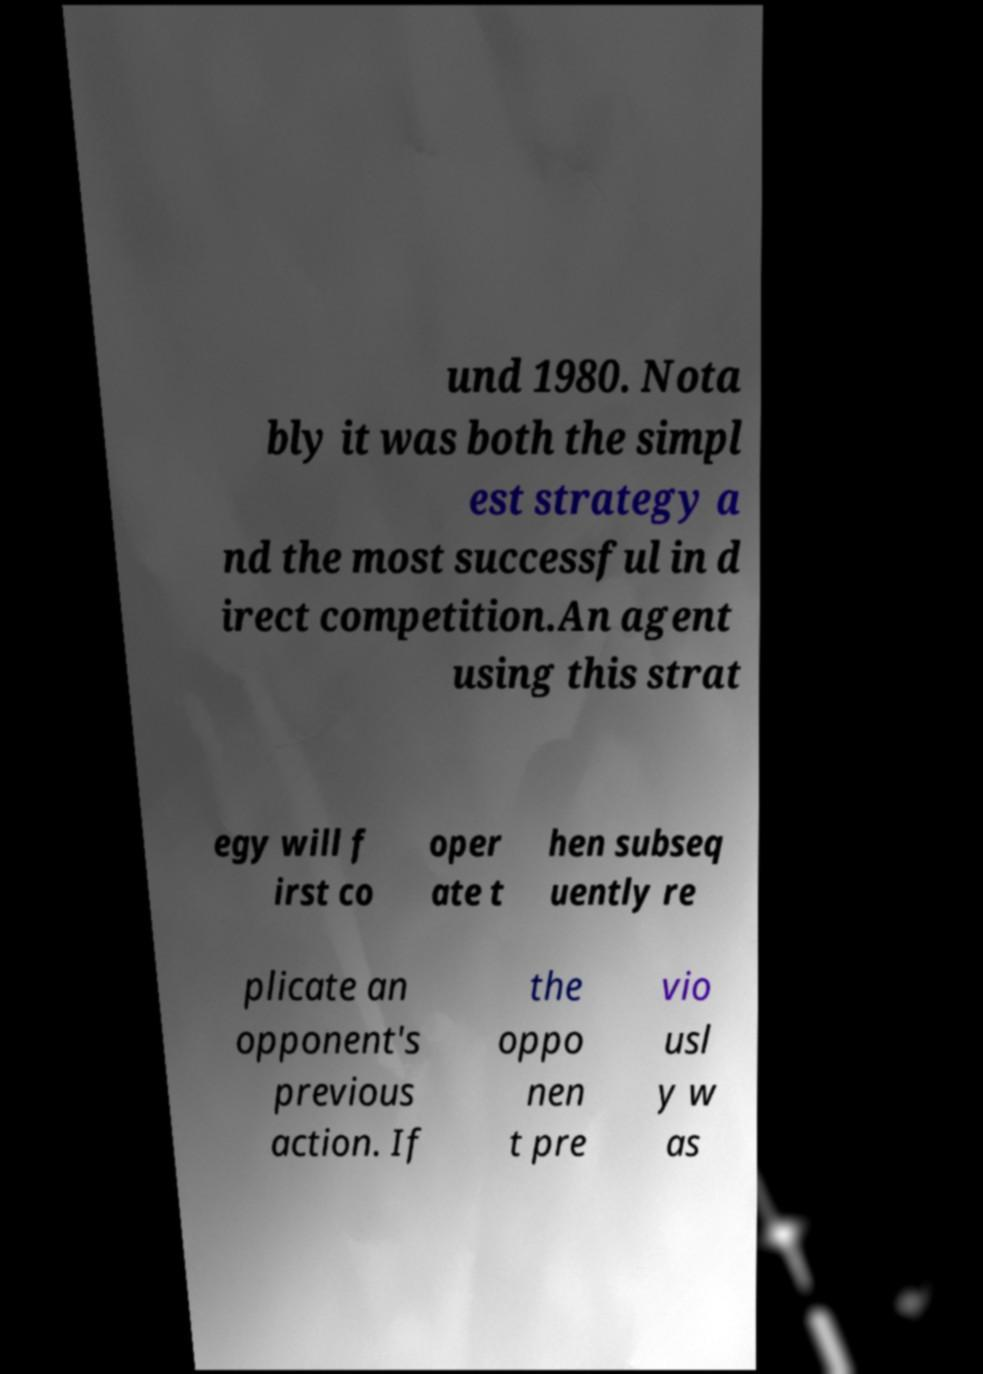Could you assist in decoding the text presented in this image and type it out clearly? und 1980. Nota bly it was both the simpl est strategy a nd the most successful in d irect competition.An agent using this strat egy will f irst co oper ate t hen subseq uently re plicate an opponent's previous action. If the oppo nen t pre vio usl y w as 